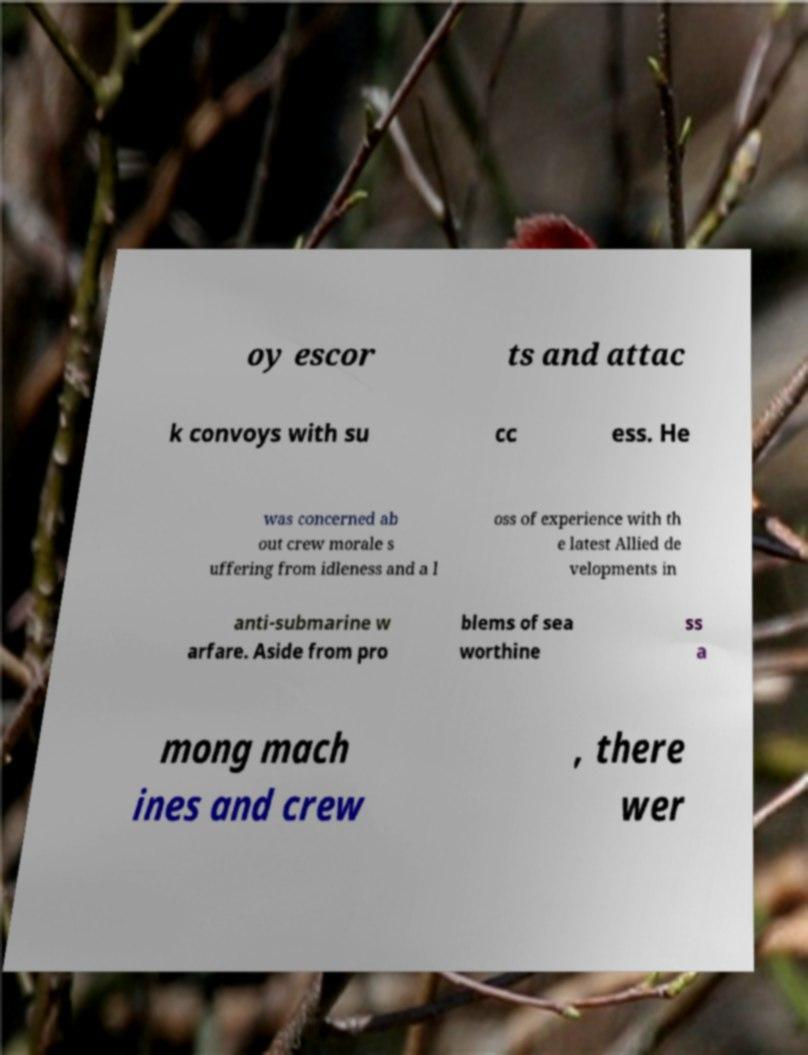Could you extract and type out the text from this image? oy escor ts and attac k convoys with su cc ess. He was concerned ab out crew morale s uffering from idleness and a l oss of experience with th e latest Allied de velopments in anti-submarine w arfare. Aside from pro blems of sea worthine ss a mong mach ines and crew , there wer 